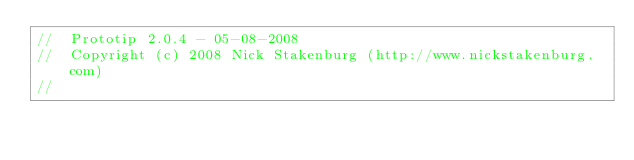<code> <loc_0><loc_0><loc_500><loc_500><_JavaScript_>//  Prototip 2.0.4 - 05-08-2008
//  Copyright (c) 2008 Nick Stakenburg (http://www.nickstakenburg.com)
//</code> 